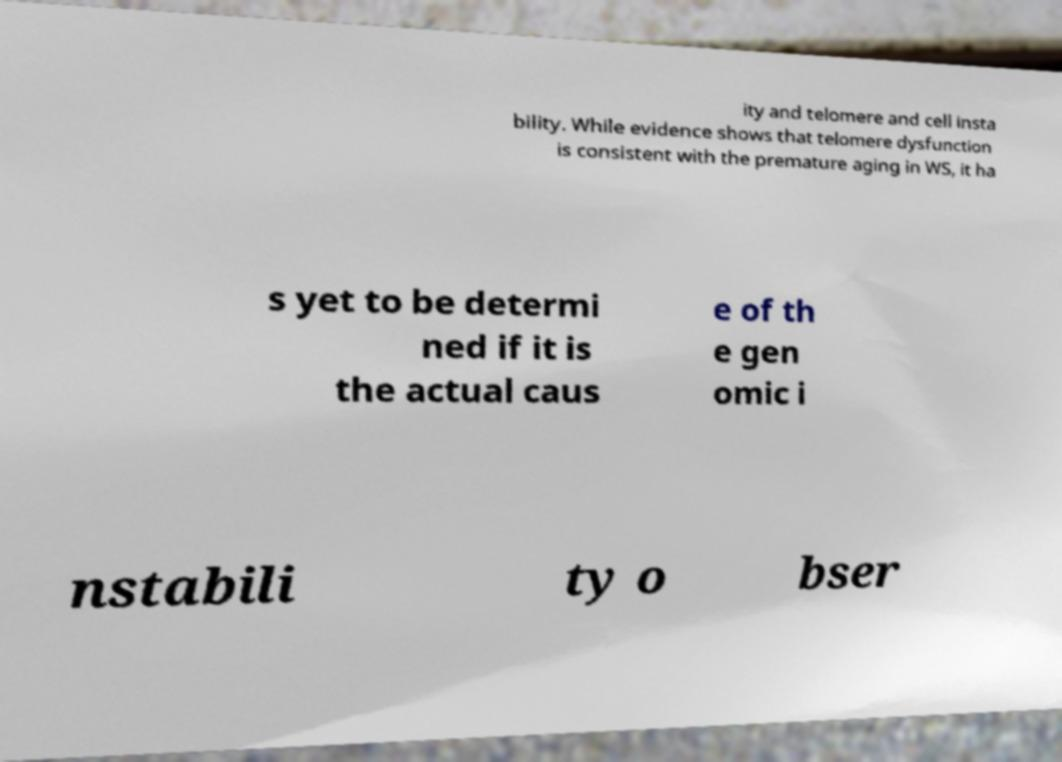There's text embedded in this image that I need extracted. Can you transcribe it verbatim? ity and telomere and cell insta bility. While evidence shows that telomere dysfunction is consistent with the premature aging in WS, it ha s yet to be determi ned if it is the actual caus e of th e gen omic i nstabili ty o bser 